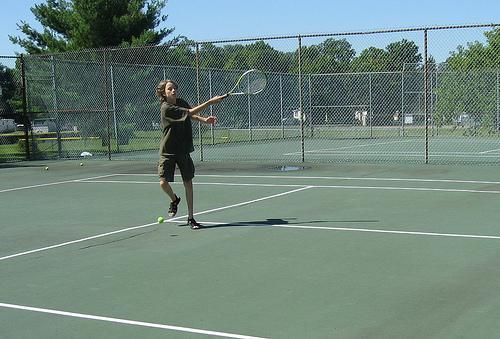How many kids are playing tennis?
Give a very brief answer. 1. 